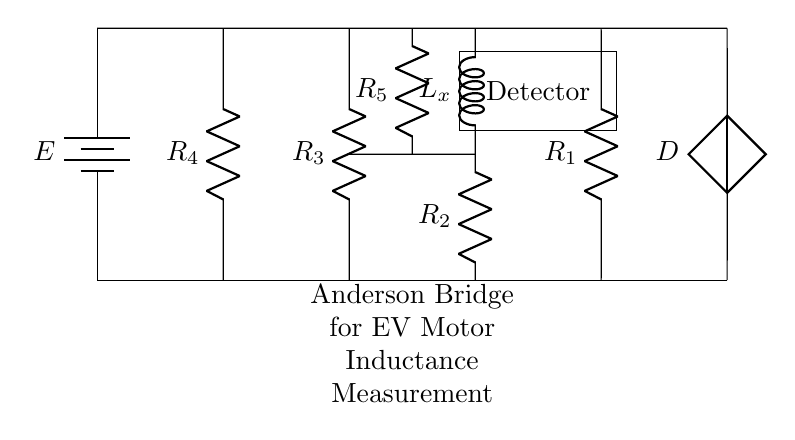What component is used to measure inductance in this circuit? The circuit includes an inductor labeled L_x, which is the component used to measure inductance.
Answer: L_x What type of bridge is this circuit? The title indicates that this is an Anderson Bridge, which is a circuit configuration specifically designed for measuring inductance.
Answer: Anderson Bridge How many resistors are present in the circuit? The circuit diagram shows four resistors labeled R_1, R_2, R_3, and R_4, making a total of four resistors.
Answer: 4 What is the purpose of the detector in this circuit? The detector is used to measure the voltage or current in the circuit, allowing for the determination of the inductance value from the balance conditions of the bridge.
Answer: Measure voltage What is the function of the battery in the circuit? The battery labeled E provides the necessary electrical power for the operation of the circuit, allowing current to flow through the components.
Answer: Provide power What is the role of resistor R_5 in the bridge? Resistor R_5 is included in the circuit to help balance the bridge and to adjust the measurement conditions, affecting the overall inductance measurement.
Answer: Balance the bridge What type of voltage source is shown in this circuit? The diagram includes a controlled voltage source labeled D, indicating that it is used to supply a specific voltage as needed by the circuit configuration.
Answer: Controlled voltage source 